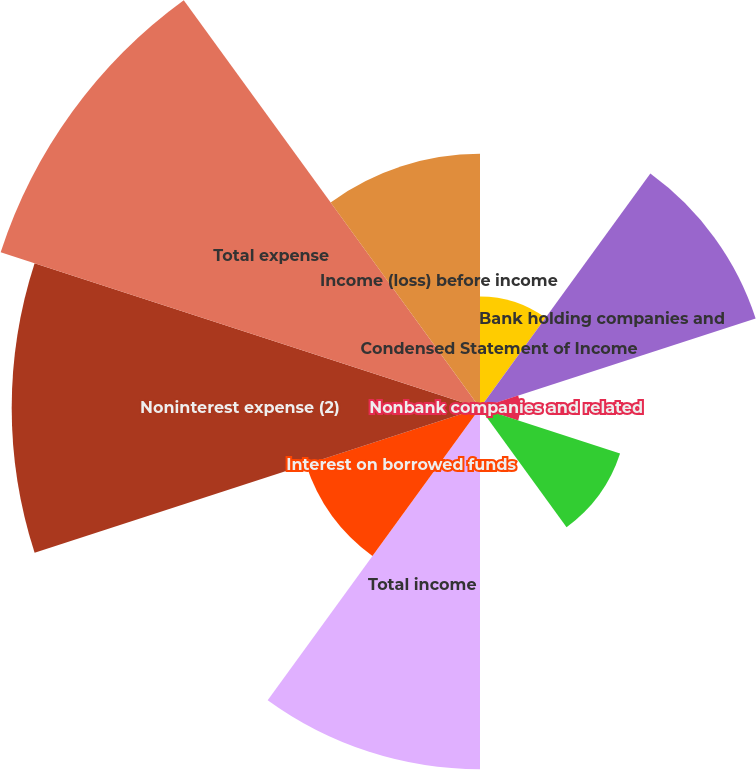Convert chart. <chart><loc_0><loc_0><loc_500><loc_500><pie_chart><fcel>Condensed Statement of Income<fcel>Bank holding companies and<fcel>Nonbank companies and related<fcel>Interest from subsidiaries<fcel>Other income (loss) (1)<fcel>Total income<fcel>Interest on borrowed funds<fcel>Noninterest expense (2)<fcel>Total expense<fcel>Income (loss) before income<nl><fcel>4.72%<fcel>12.26%<fcel>1.7%<fcel>6.23%<fcel>0.19%<fcel>15.28%<fcel>7.74%<fcel>19.81%<fcel>21.32%<fcel>10.75%<nl></chart> 